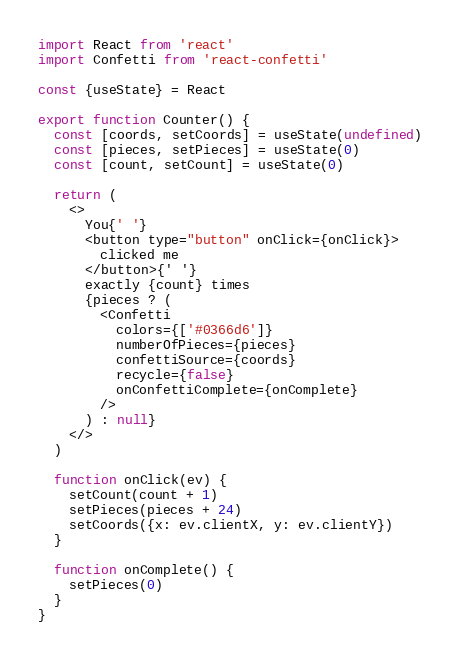Convert code to text. <code><loc_0><loc_0><loc_500><loc_500><_JavaScript_>import React from 'react'
import Confetti from 'react-confetti'

const {useState} = React

export function Counter() {
  const [coords, setCoords] = useState(undefined)
  const [pieces, setPieces] = useState(0)
  const [count, setCount] = useState(0)

  return (
    <>
      You{' '}
      <button type="button" onClick={onClick}>
        clicked me
      </button>{' '}
      exactly {count} times
      {pieces ? (
        <Confetti
          colors={['#0366d6']}
          numberOfPieces={pieces}
          confettiSource={coords}
          recycle={false}
          onConfettiComplete={onComplete}
        />
      ) : null}
    </>
  )

  function onClick(ev) {
    setCount(count + 1)
    setPieces(pieces + 24)
    setCoords({x: ev.clientX, y: ev.clientY})
  }

  function onComplete() {
    setPieces(0)
  }
}
</code> 